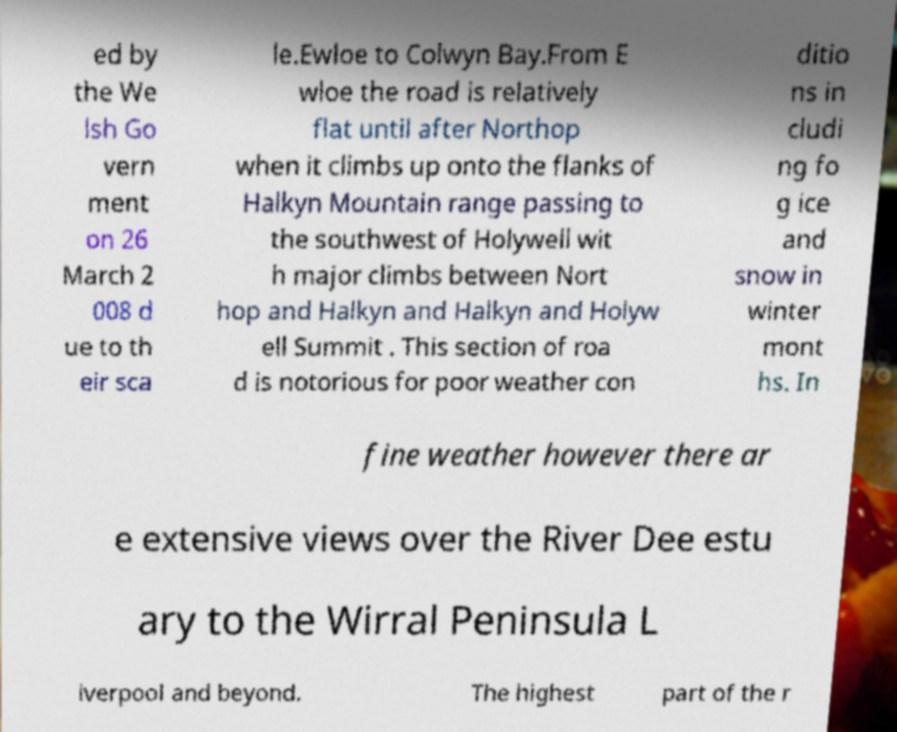Could you assist in decoding the text presented in this image and type it out clearly? ed by the We lsh Go vern ment on 26 March 2 008 d ue to th eir sca le.Ewloe to Colwyn Bay.From E wloe the road is relatively flat until after Northop when it climbs up onto the flanks of Halkyn Mountain range passing to the southwest of Holywell wit h major climbs between Nort hop and Halkyn and Halkyn and Holyw ell Summit . This section of roa d is notorious for poor weather con ditio ns in cludi ng fo g ice and snow in winter mont hs. In fine weather however there ar e extensive views over the River Dee estu ary to the Wirral Peninsula L iverpool and beyond. The highest part of the r 